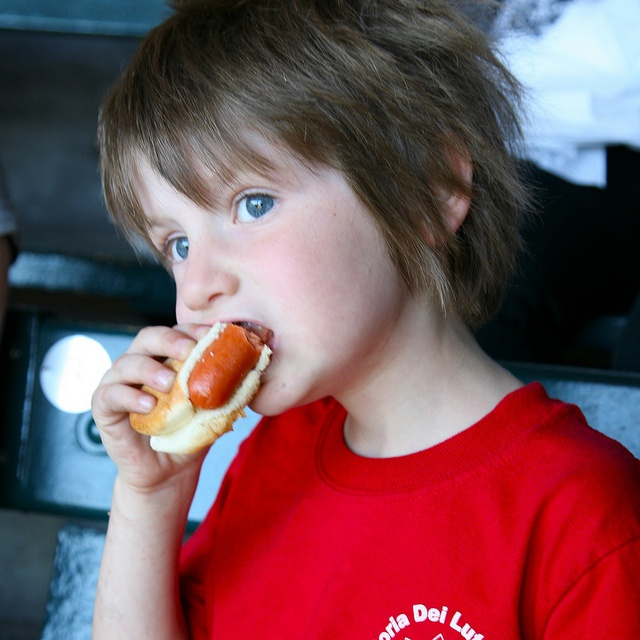Describe the objects in this image and their specific colors. I can see people in blue, black, brown, and lightgray tones and hot dog in blue, ivory, tan, and red tones in this image. 